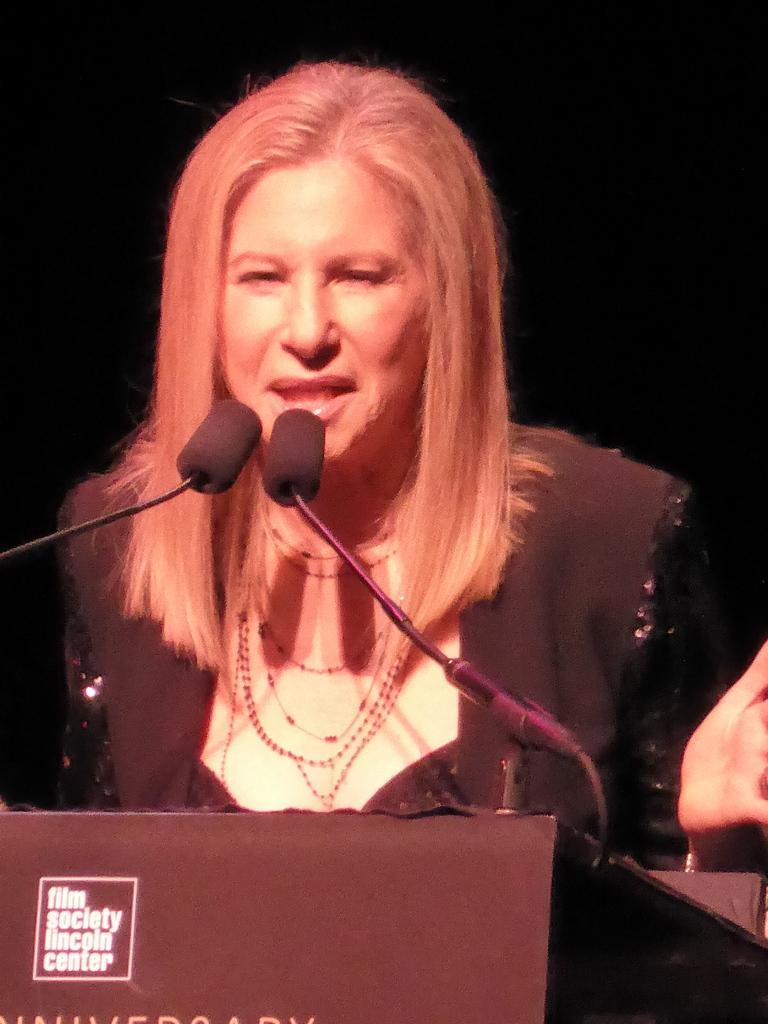Describe this image in one or two sentences. In this picture I can see there is a woman, she is speaking in the microphone and there is a wooden table in front of her and there are two microphones attached to it. The backdrop is dark. 